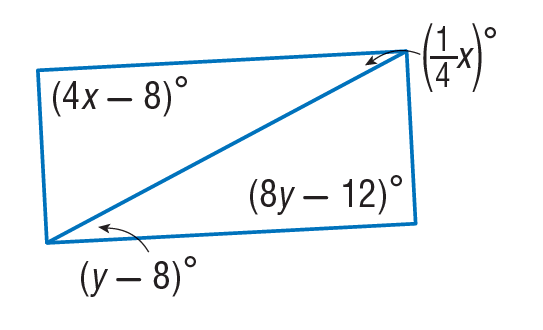Answer the mathemtical geometry problem and directly provide the correct option letter.
Question: Find x so that the quadrilateral is a parallelogram.
Choices: A: 28 B: 30 C: 90 D: 112 B 